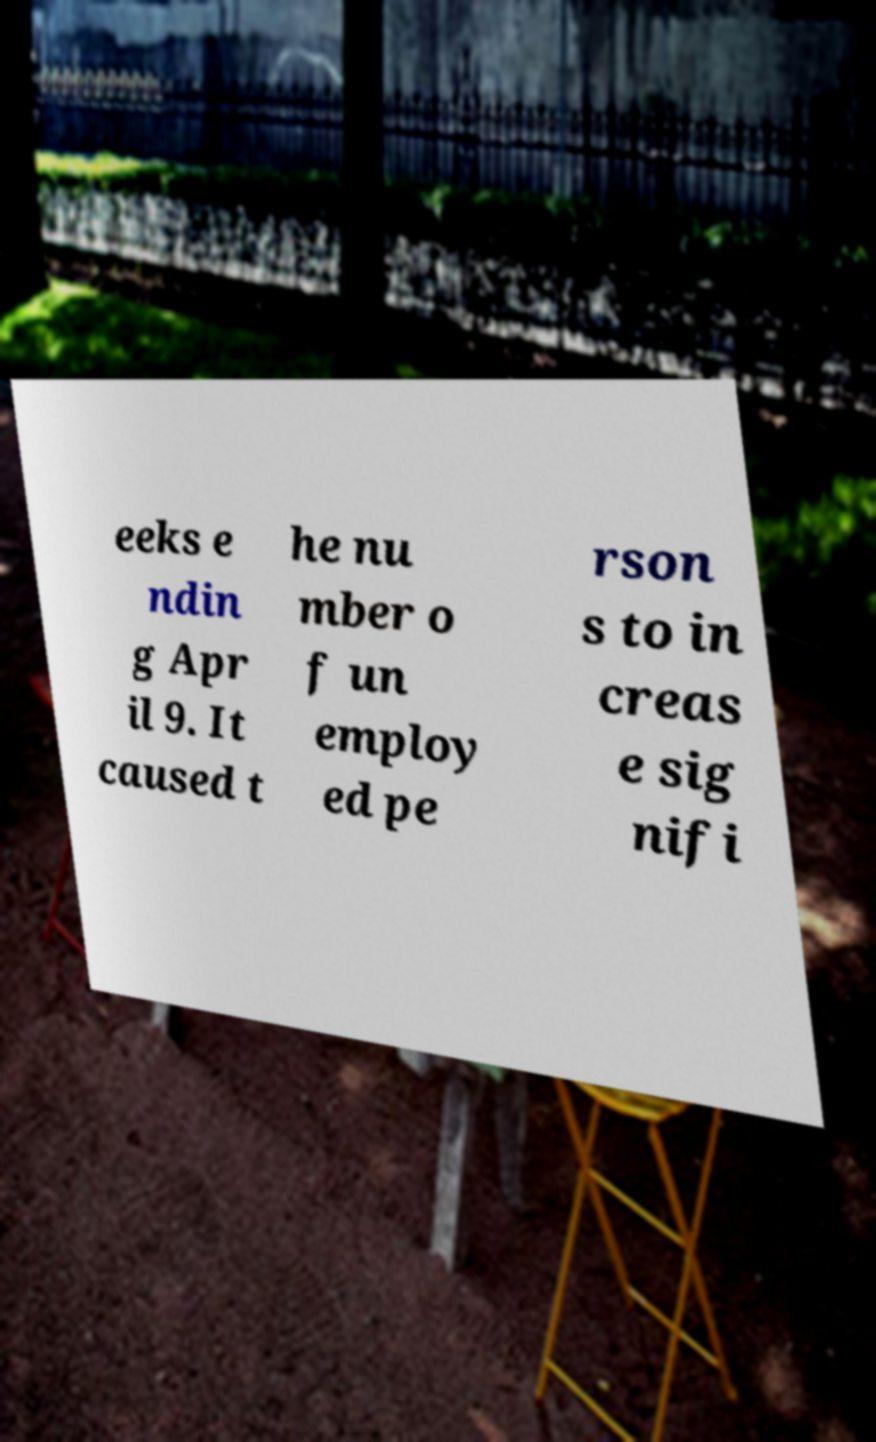Please identify and transcribe the text found in this image. eeks e ndin g Apr il 9. It caused t he nu mber o f un employ ed pe rson s to in creas e sig nifi 